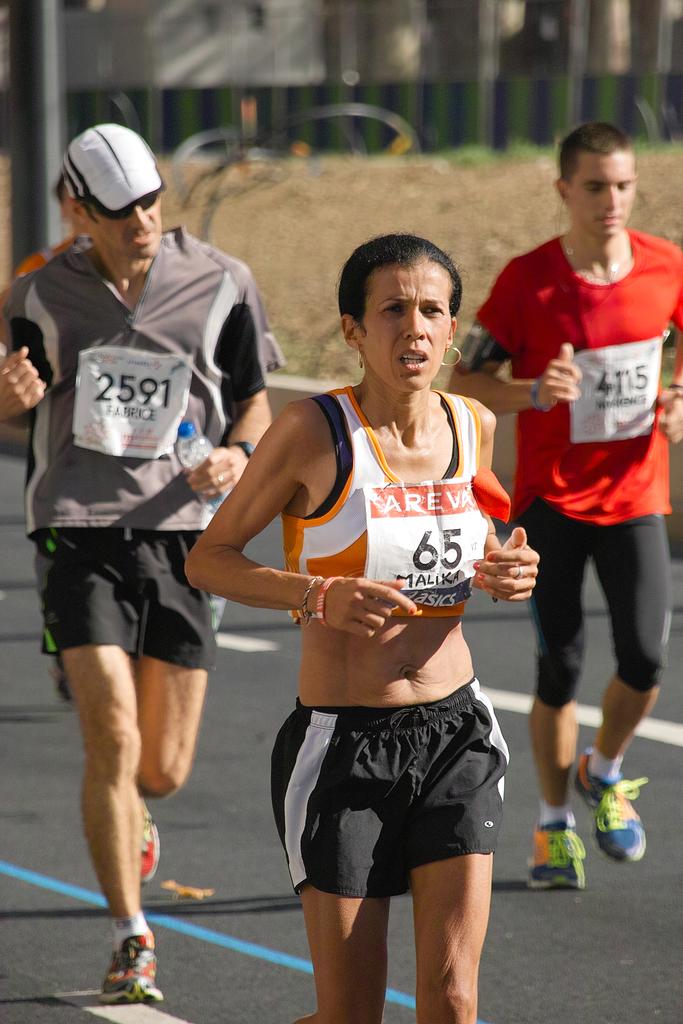What participation number is the woman athlete wearing?
Make the answer very short. 65. What number is the woman wearing?
Your answer should be compact. 65. 